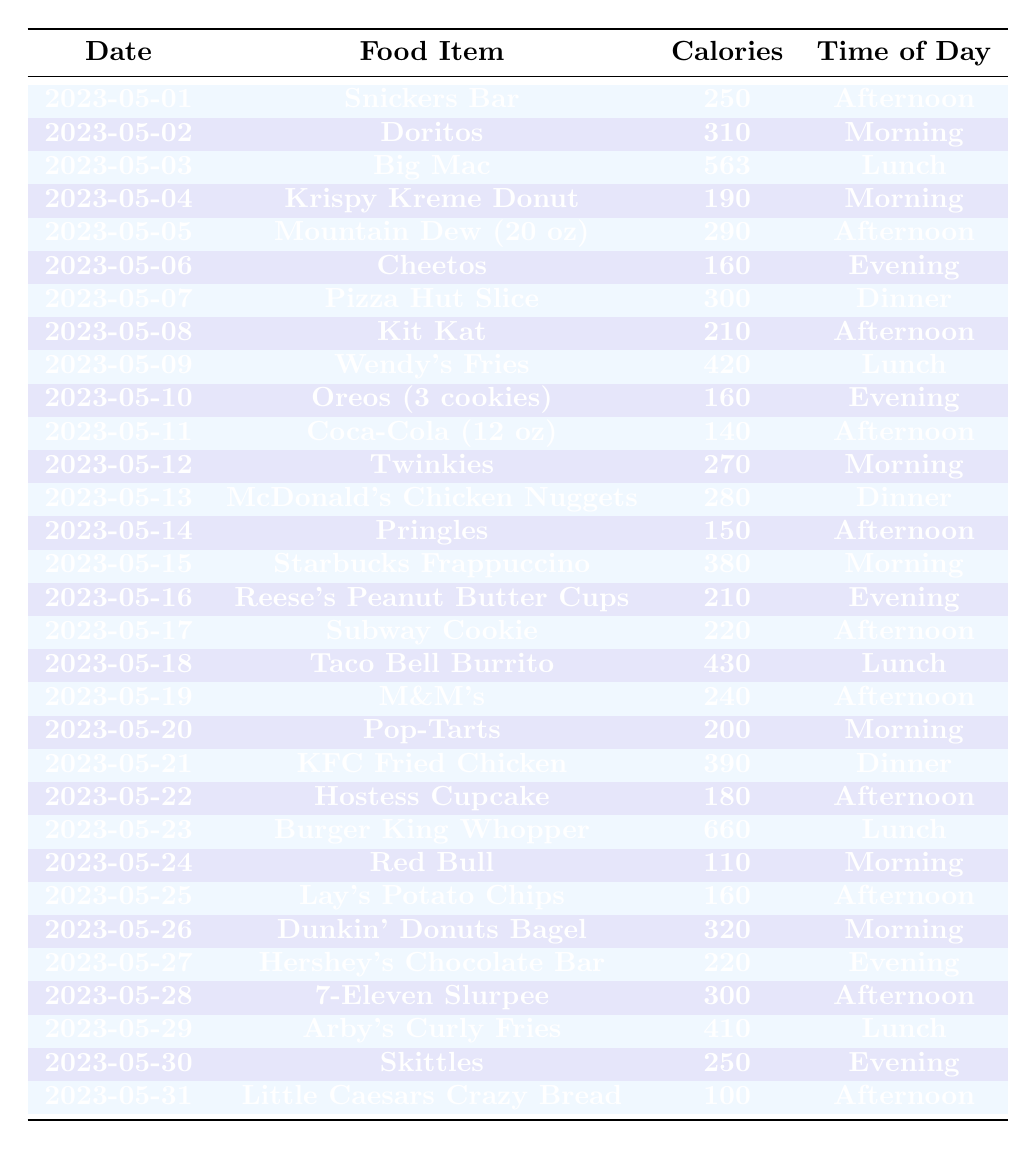What was the highest calorie food item consumed? The table lists all food items along with their calorie counts. Scanning through the calorie column, the highest value is 660, associated with the "Burger King Whopper."
Answer: Burger King Whopper How many calories were consumed on May 15? Referring to the row for May 15, the food item is "Starbucks Frappuccino," which has 380 calories.
Answer: 380 What is the average calorie intake from junk food over the month? To calculate the average, first sum all the calorie values, which in this case yields 6750. There are 31 entries (days). The average is 6750 divided by 31, which is approximately 217.74.
Answer: 217.74 Which food item was consumed most frequently per the table? Observing the food items, a few appear multiple times, like "Cheetos," "Twinkies," etc. Counting shows "Cheetos" appears only once, so no item is repeated. The answer is there is no dominant food item consumed more than once.
Answer: No dominant item Was a donut consumed in the morning? Looking at the morning entries in the table, one such food item listed is "Krispy Kreme Donut" on May 4. So the statement is true.
Answer: Yes How many calories were consumed in the evening throughout the month? The total calories for the evening items can be calculated by summing their respective calorie values: 160 (Cheetos) + 160 (Oreos) + 210 (Reese's) + 220 (Subway Cookie) + 300 (7-Eleven Slurpee) = 1050.
Answer: 1050 What day had a calorie count of less than 200? By scanning each date against the calorie values, the table shows that on May 24, "Red Bull" had 110 calories, which is indeed less than 200.
Answer: May 24 Which food item had the highest calorie count during lunch? In the lunch entries, there are items like "Big Mac" (563 calories), "Wendy's Fries" (420), and "Burger King Whopper" (660). The highest among them is the "Burger King Whopper."
Answer: Burger King Whopper How many food items had calories greater than 400? By reviewing the calorie counts for all items, those above 400 are "Big Mac" (563), "Wendy's Fries" (420), "Taco Bell Burrito" (430), and "Burger King Whopper" (660). In total, there are 4 items.
Answer: 4 Were items consumed more in the afternoon or morning? Checking the table, there are 15 entries for Afternoon and 10 for Morning. This shows that more items were indeed consumed in the Afternoon.
Answer: Afternoon 